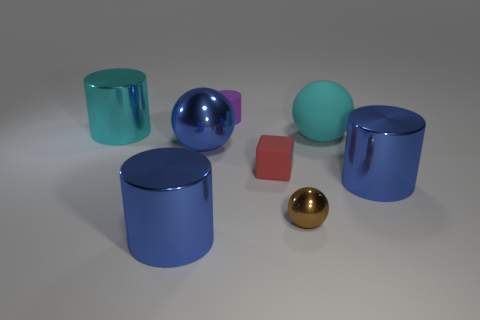How many other things are there of the same color as the block?
Your answer should be very brief. 0. How many purple things are either cubes or tiny rubber things?
Provide a short and direct response. 1. There is a small purple object right of the cyan metallic thing; what material is it?
Ensure brevity in your answer.  Rubber. Is the cylinder that is to the right of the small purple object made of the same material as the big blue ball?
Keep it short and to the point. Yes. What shape is the small brown shiny object?
Give a very brief answer. Sphere. There is a large metal thing that is on the right side of the rubber object behind the cyan metal object; how many metal things are behind it?
Give a very brief answer. 2. How many other objects are there of the same material as the tiny cylinder?
Your response must be concise. 2. There is a block that is the same size as the purple thing; what is it made of?
Offer a very short reply. Rubber. Does the thing behind the big cyan cylinder have the same color as the cylinder to the right of the tiny purple object?
Give a very brief answer. No. Is there a big yellow rubber thing of the same shape as the tiny brown object?
Your answer should be compact. No. 